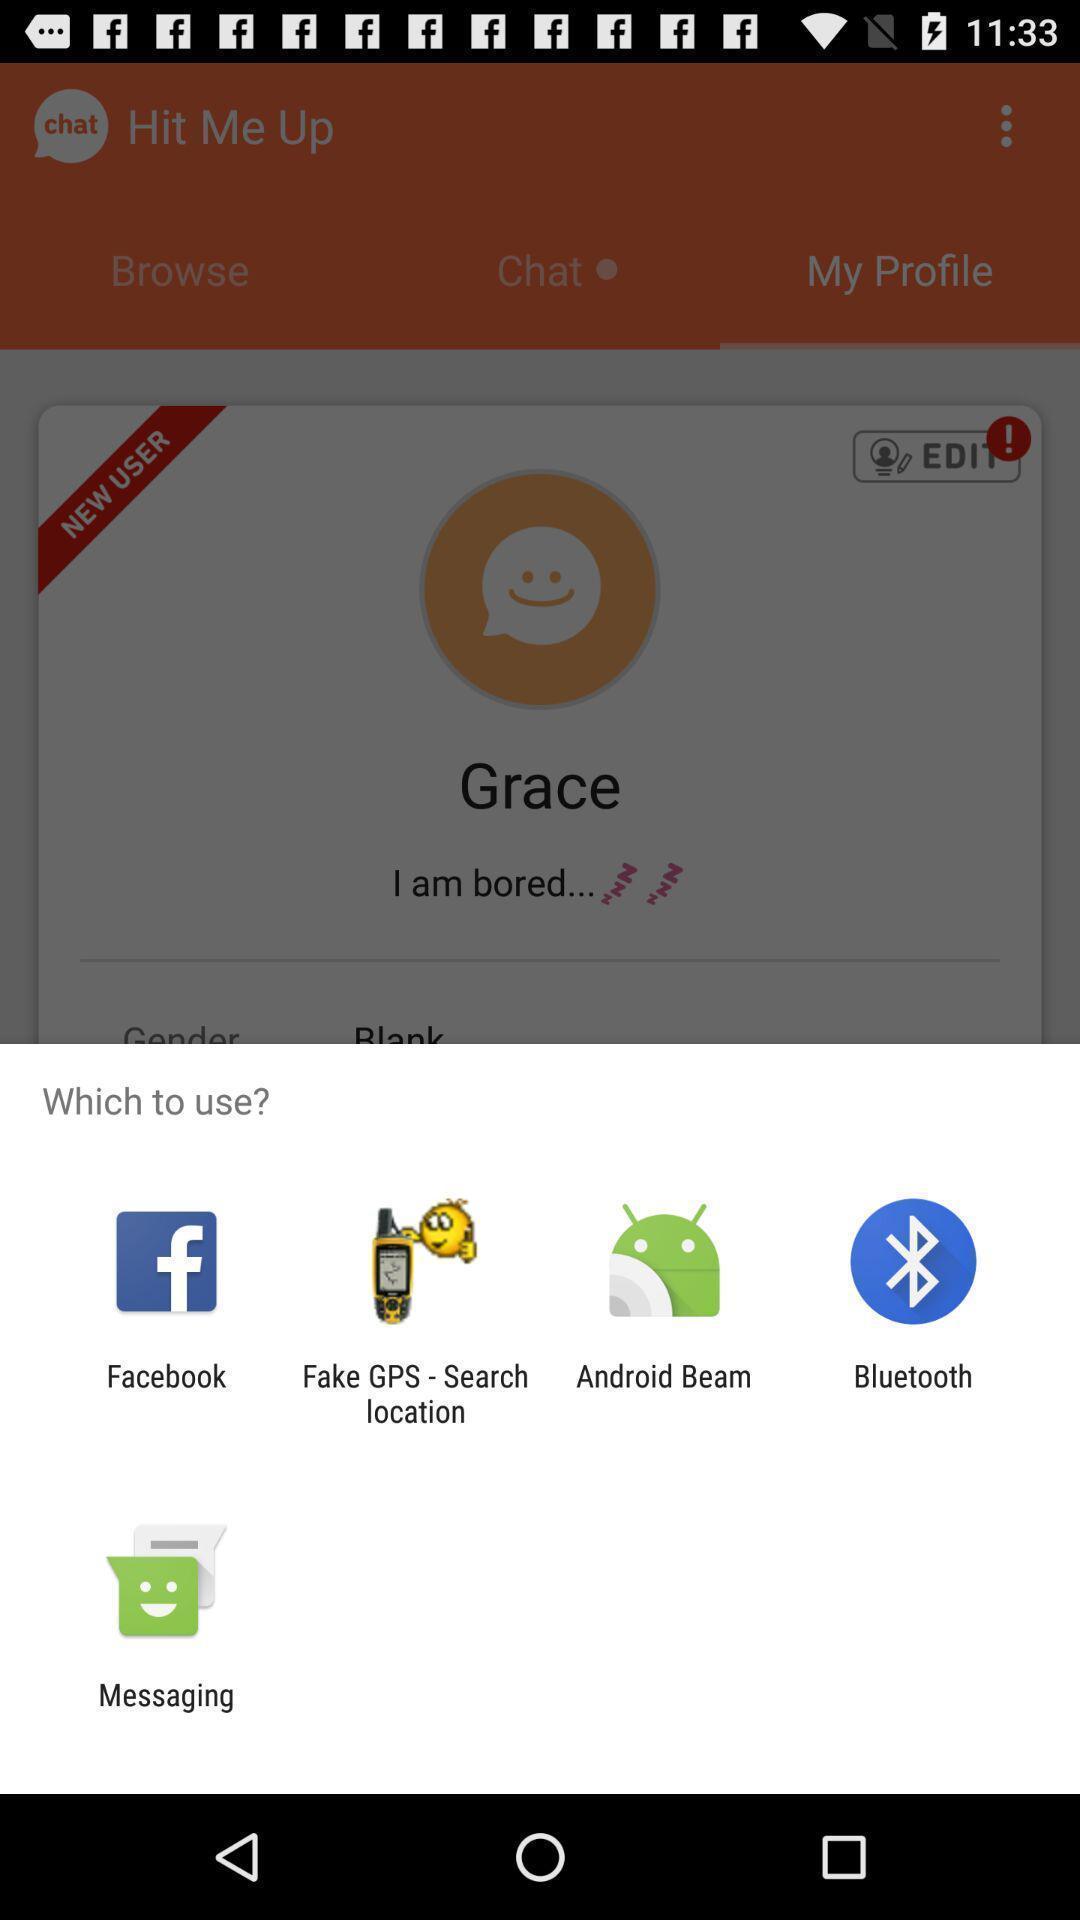Describe the content in this image. Popup of apps to use. 